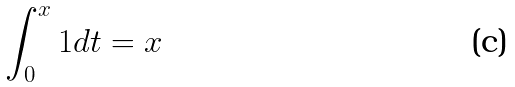<formula> <loc_0><loc_0><loc_500><loc_500>\int _ { 0 } ^ { x } 1 d t = x</formula> 